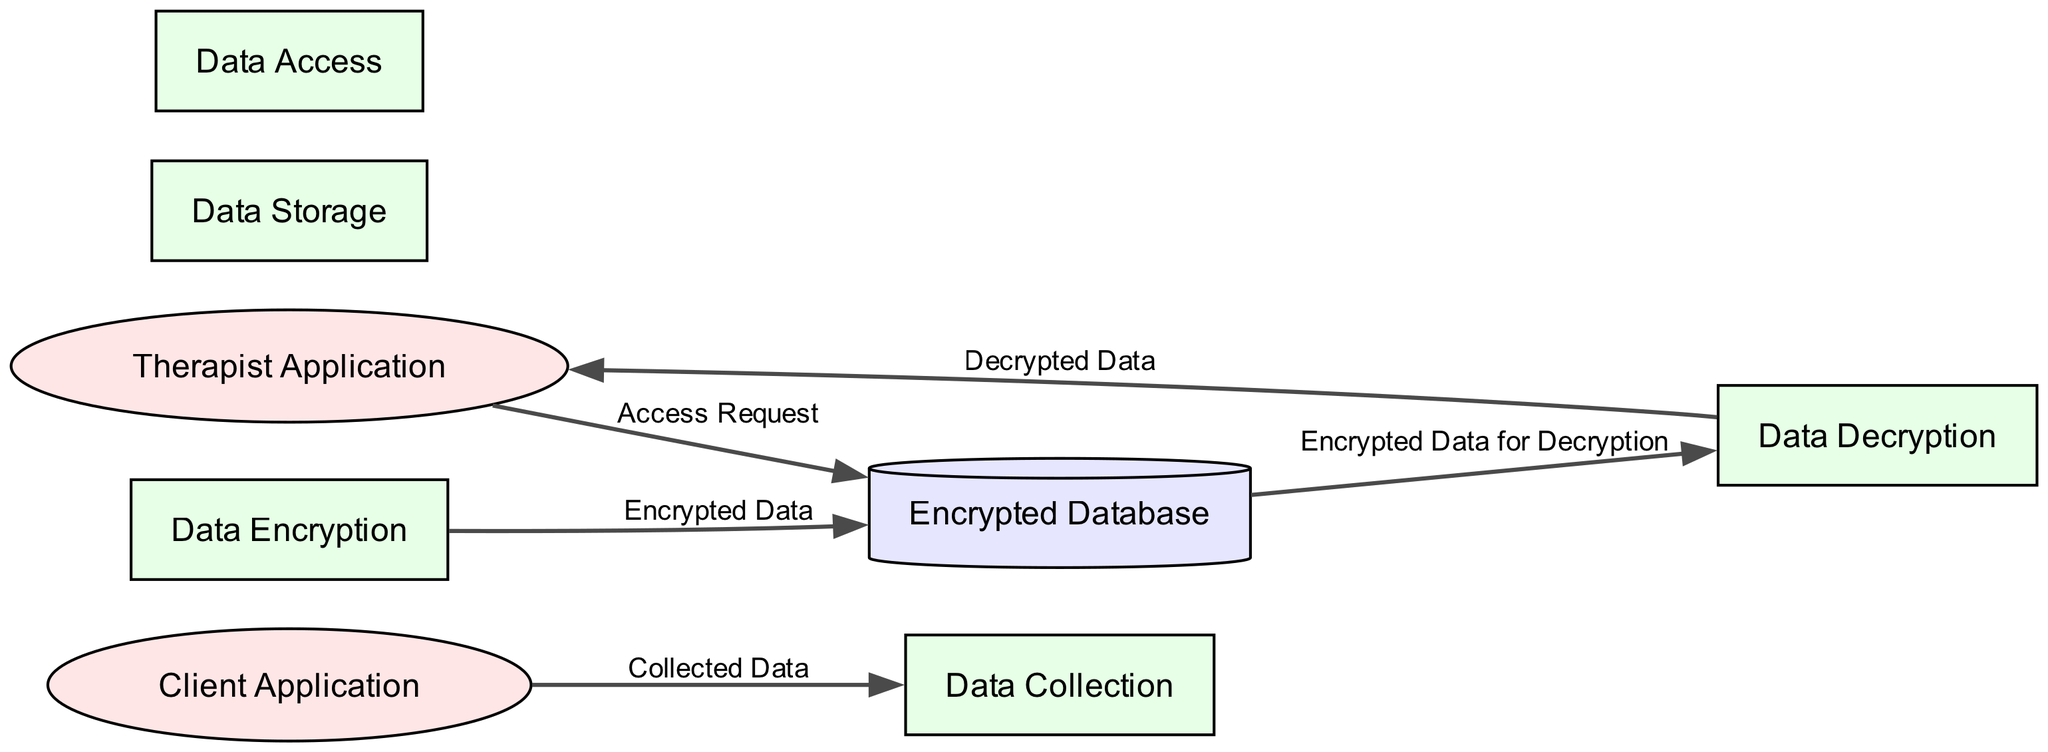What is the name of the external entity used by patients? The diagram indicates that the external entity used by patients is called the "Client Application."
Answer: Client Application How many processes are depicted in the diagram? By counting the listed processes, we find five distinct processes: Data Collection, Data Encryption, Data Storage, Data Access, and Data Decryption.
Answer: Five What data flows from the Client Application to the Data Collection process? The flow from the Client Application to the Data Collection process is labeled "Collected Data."
Answer: Collected Data Which process is responsible for encrypting patient data? The diagram specifies that the process responsible for encrypting patient data is called "Data Encryption."
Answer: Data Encryption What is the destination of the flow labeled "Encrypted Data"? The flow labeled "Encrypted Data" is directed towards the "Encrypted Database."
Answer: Encrypted Database How many external entities are displayed in the diagram? There are two external entities shown: the Client Application and the Therapist Application, making a total of two.
Answer: Two What type of data does the Therapist Application access? The diagram reveals that the Therapist Application accesses "Decrypted Data," which is processed after decryption.
Answer: Decrypted Data What is the source of the flow that goes to the Data Decryption process? The flow to the Data Decryption process is sourced from the "Encrypted Database," which holds the encrypted patient data.
Answer: Encrypted Database Which process follows the Data Access process in terms of receiving data? The process that follows Data Access is "Data Decryption," where the encrypted data is decrypted for viewing.
Answer: Data Decryption 